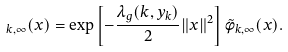<formula> <loc_0><loc_0><loc_500><loc_500>_ { k , \infty } ( x ) = \exp \left [ - \frac { \lambda _ { g } ( k , y _ { k } ) } { 2 } \| x \| ^ { 2 } \right ] \tilde { \phi } _ { k , \infty } ( x ) .</formula> 